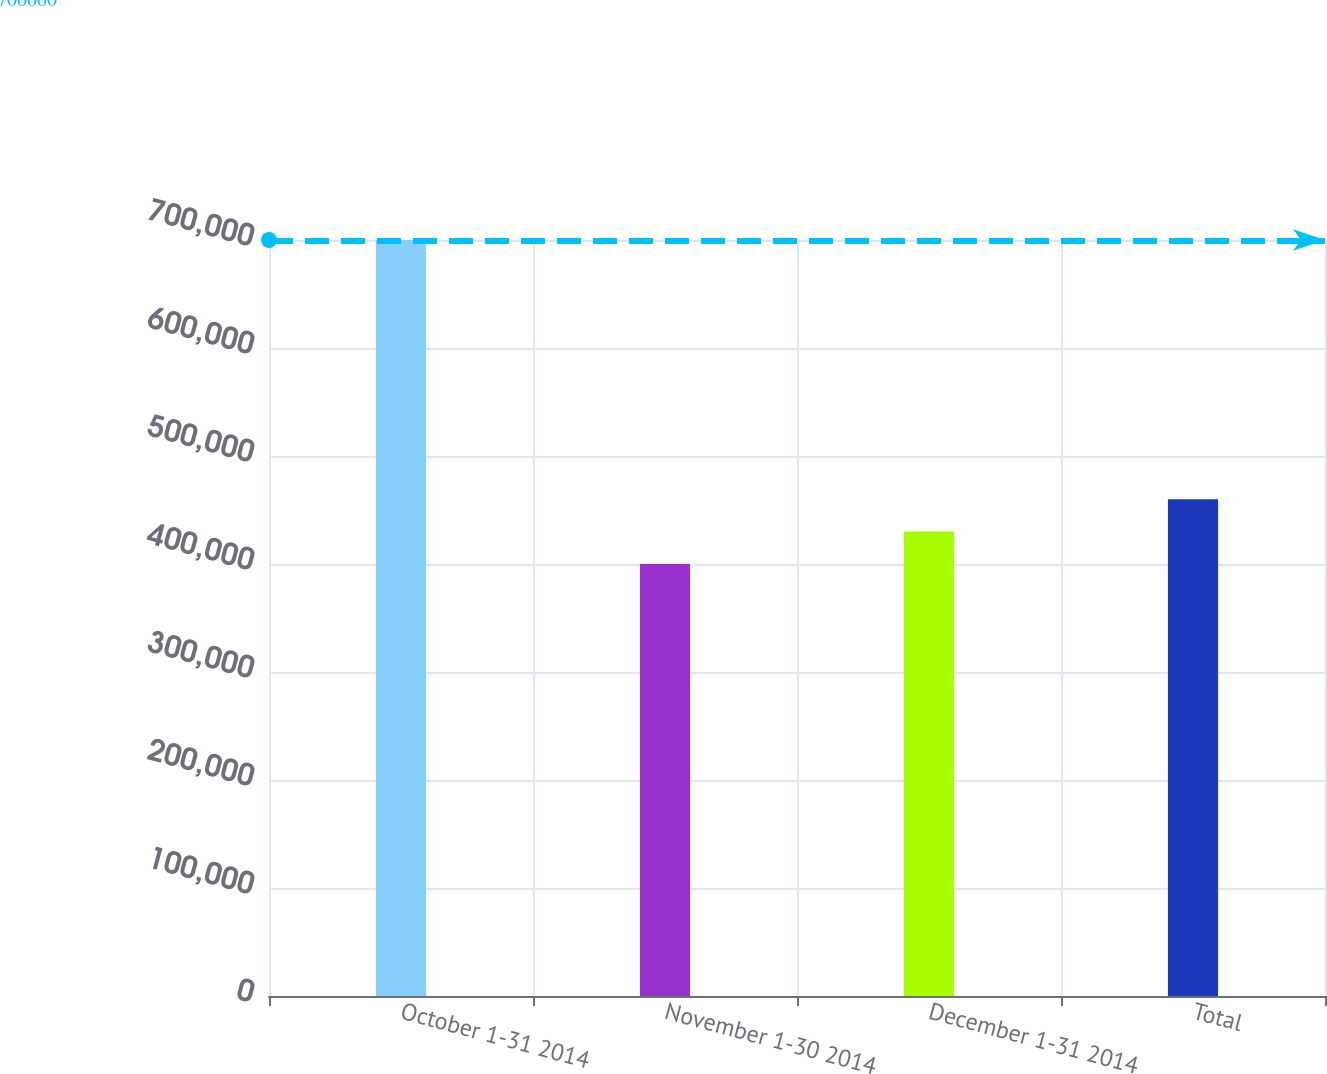<chart> <loc_0><loc_0><loc_500><loc_500><bar_chart><fcel>October 1-31 2014<fcel>November 1-30 2014<fcel>December 1-31 2014<fcel>Total<nl><fcel>700000<fcel>400000<fcel>430000<fcel>460000<nl></chart> 